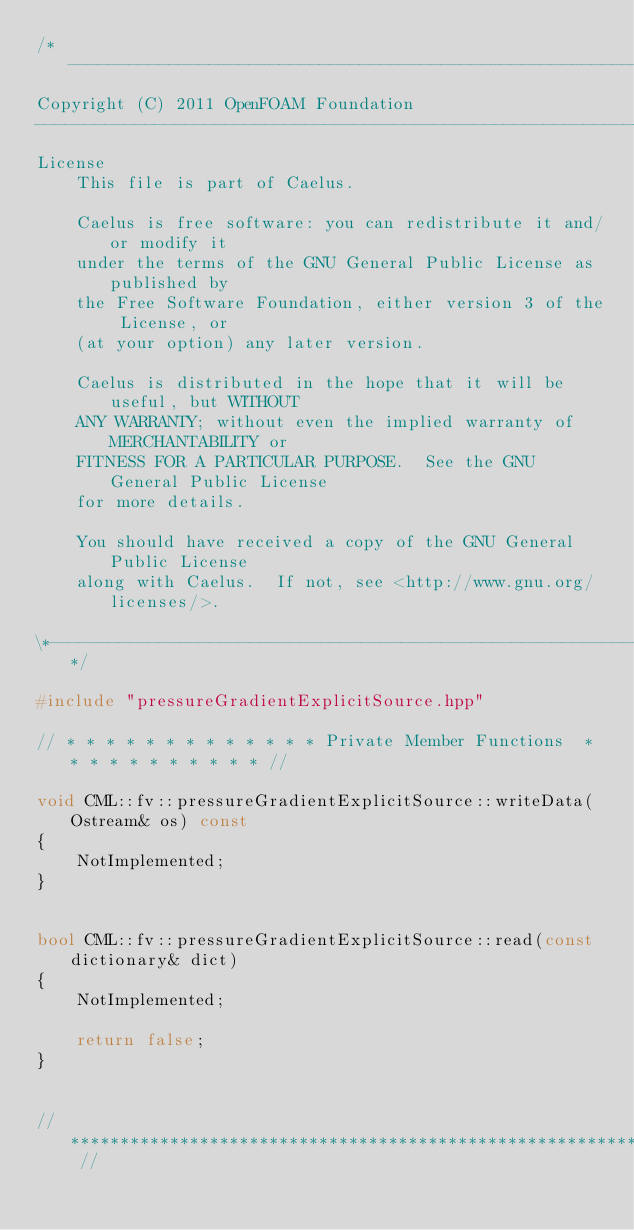Convert code to text. <code><loc_0><loc_0><loc_500><loc_500><_C++_>/*---------------------------------------------------------------------------*\
Copyright (C) 2011 OpenFOAM Foundation
-------------------------------------------------------------------------------
License
    This file is part of Caelus.

    Caelus is free software: you can redistribute it and/or modify it
    under the terms of the GNU General Public License as published by
    the Free Software Foundation, either version 3 of the License, or
    (at your option) any later version.

    Caelus is distributed in the hope that it will be useful, but WITHOUT
    ANY WARRANTY; without even the implied warranty of MERCHANTABILITY or
    FITNESS FOR A PARTICULAR PURPOSE.  See the GNU General Public License
    for more details.

    You should have received a copy of the GNU General Public License
    along with Caelus.  If not, see <http://www.gnu.org/licenses/>.

\*---------------------------------------------------------------------------*/

#include "pressureGradientExplicitSource.hpp"

// * * * * * * * * * * * * * Private Member Functions  * * * * * * * * * * * //

void CML::fv::pressureGradientExplicitSource::writeData(Ostream& os) const
{
    NotImplemented;
}


bool CML::fv::pressureGradientExplicitSource::read(const dictionary& dict)
{
    NotImplemented;

    return false;
}


// ************************************************************************* //
</code> 